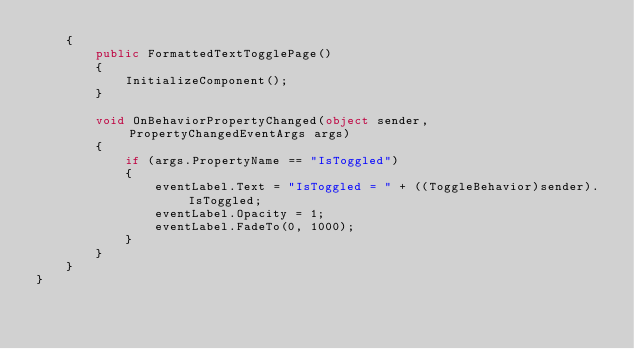Convert code to text. <code><loc_0><loc_0><loc_500><loc_500><_C#_>    {
        public FormattedTextTogglePage()
        {
            InitializeComponent();
        }

        void OnBehaviorPropertyChanged(object sender, PropertyChangedEventArgs args)
        {
            if (args.PropertyName == "IsToggled")
            {
                eventLabel.Text = "IsToggled = " + ((ToggleBehavior)sender).IsToggled;
                eventLabel.Opacity = 1;
                eventLabel.FadeTo(0, 1000);
            }
        }
    }
}
</code> 